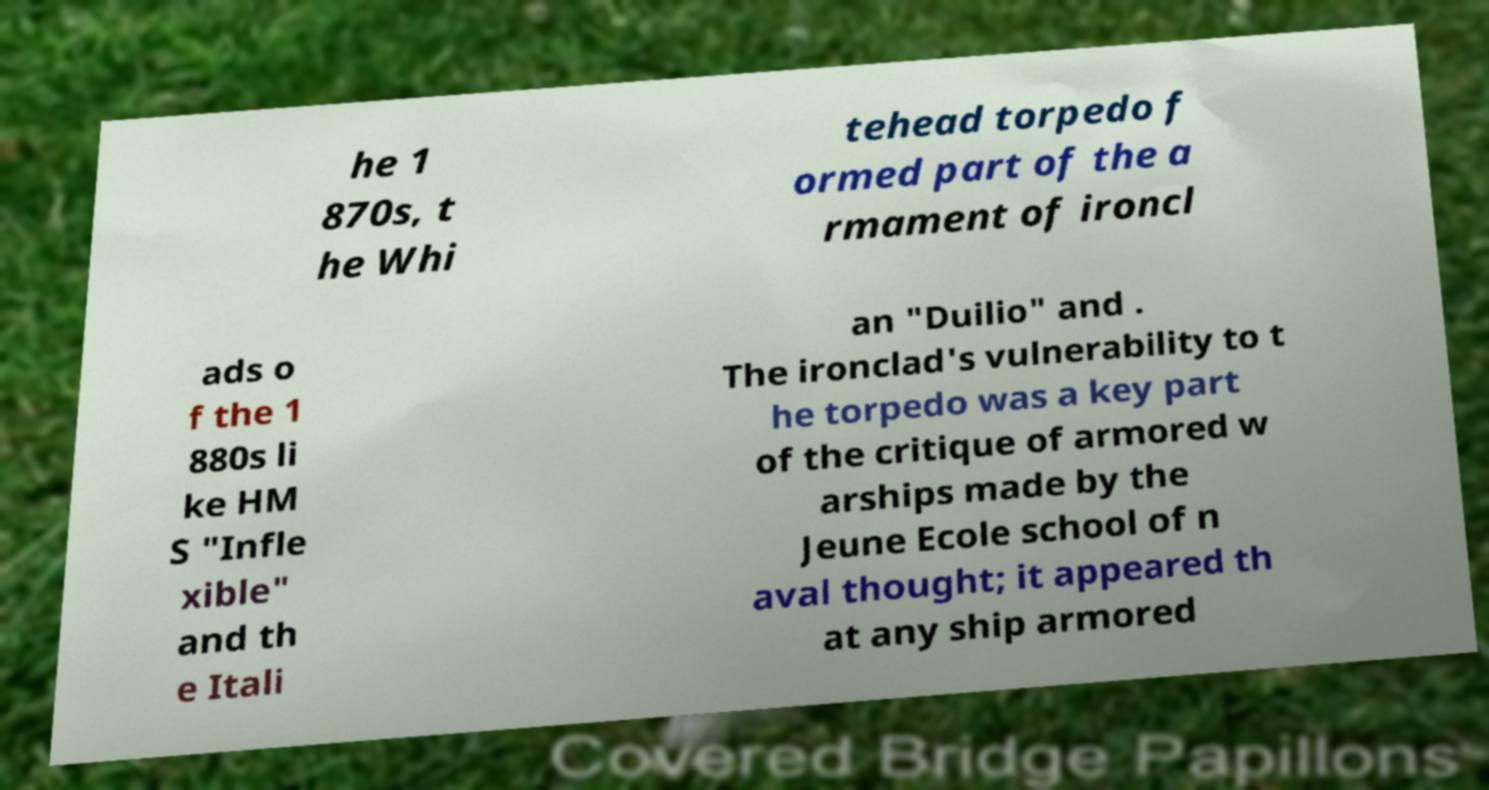What messages or text are displayed in this image? I need them in a readable, typed format. he 1 870s, t he Whi tehead torpedo f ormed part of the a rmament of ironcl ads o f the 1 880s li ke HM S "Infle xible" and th e Itali an "Duilio" and . The ironclad's vulnerability to t he torpedo was a key part of the critique of armored w arships made by the Jeune Ecole school of n aval thought; it appeared th at any ship armored 